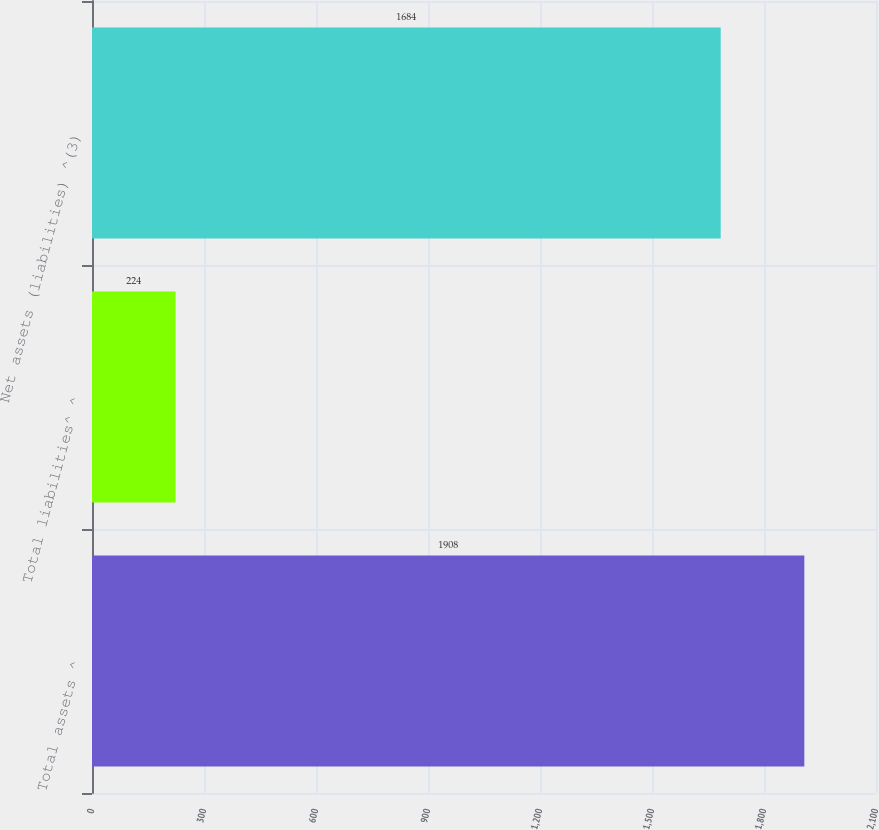Convert chart. <chart><loc_0><loc_0><loc_500><loc_500><bar_chart><fcel>Total assets ^<fcel>Total liabilities^ ^<fcel>Net assets (liabilities) ^(3)<nl><fcel>1908<fcel>224<fcel>1684<nl></chart> 